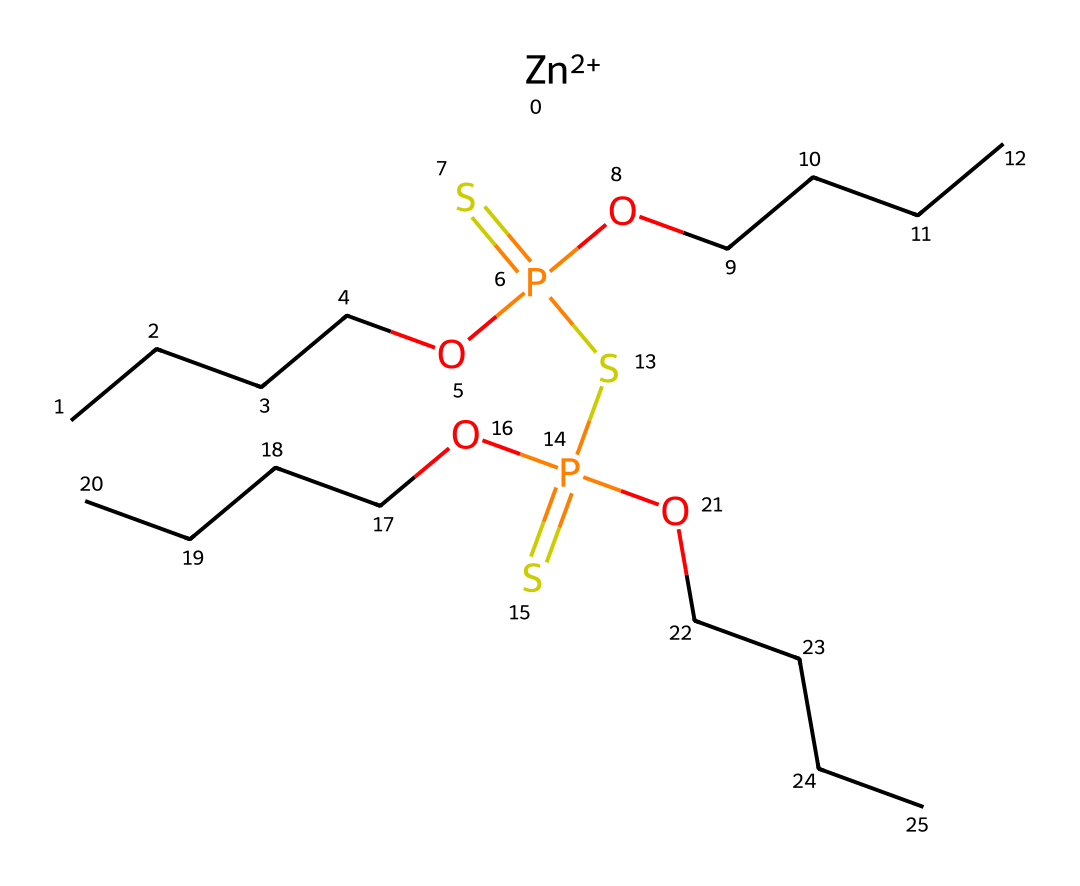What metal ion is present in this structure? The presence of the "[Zn+2]" notation in the SMILES indicates that zinc is the metal ion in this chemical structure.
Answer: zinc How many phosphorus atoms are in this chemical structure? The notation "P" appears twice in the SMILES, indicating there are two phosphorus atoms present in this structure.
Answer: two What type of bond connects the carbon chains in the structure? The carbon chains (CCCC) are connected by single bonds (represented by the implicit bonds in the SMILES notation between the C atoms), indicating they are aliphatic carbon chains.
Answer: single bonds What is the role of the phosphorus in this lubricant? Phosphorus, particularly in the form shown here with phosphorus-sulfur groups, often acts as an anti-wear and extreme-pressure additive in lubricants.
Answer: anti-wear How many sulfur atoms are present in the structure? The chemical structure contains two "S" notations, indicating there are two sulfur atoms present.
Answer: two What functional groups are present in this lubricant? The structure includes thiophosphate functional groups, evidenced by the presence of phosphorus, sulfur, and oxygen atoms, which are commonly found in such lubricating additives.
Answer: thiophosphate What does the presence of zinc indicate about the lubricant? Zinc is typically present in lubricants as a component of zinc dialkyldithiophosphate (ZDDP), an important anti-wear additive, suggesting that this lubricant has protective properties against wear.
Answer: anti-wear properties 